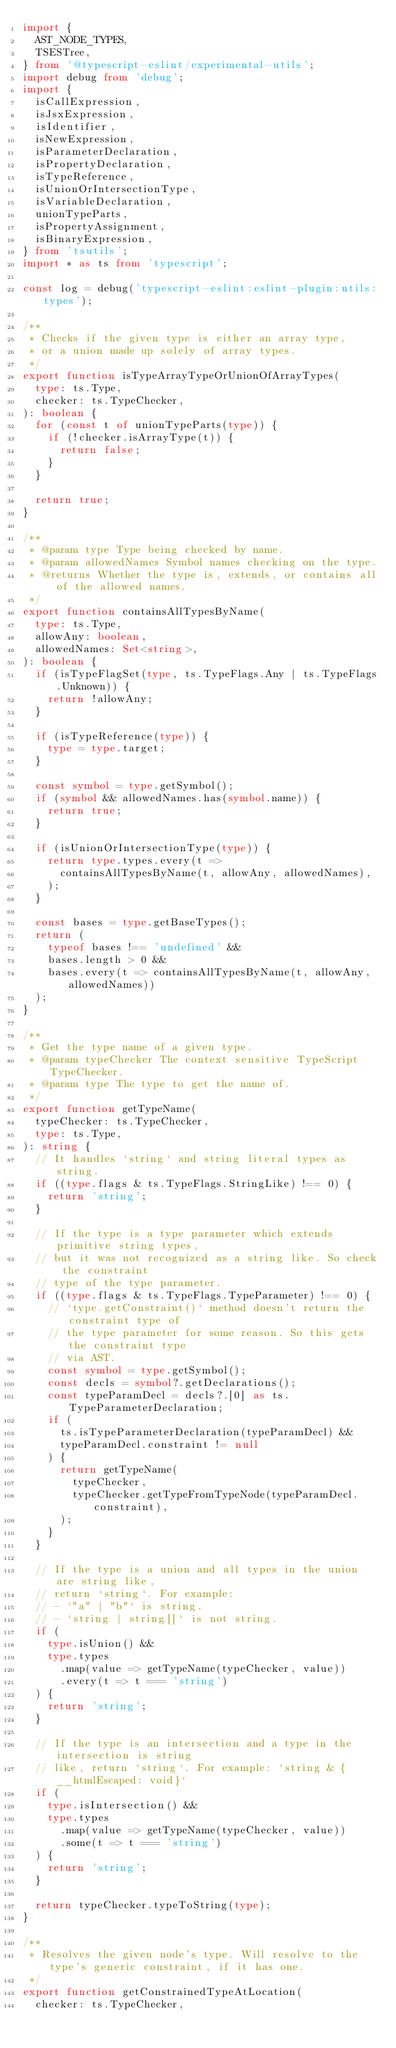<code> <loc_0><loc_0><loc_500><loc_500><_TypeScript_>import {
  AST_NODE_TYPES,
  TSESTree,
} from '@typescript-eslint/experimental-utils';
import debug from 'debug';
import {
  isCallExpression,
  isJsxExpression,
  isIdentifier,
  isNewExpression,
  isParameterDeclaration,
  isPropertyDeclaration,
  isTypeReference,
  isUnionOrIntersectionType,
  isVariableDeclaration,
  unionTypeParts,
  isPropertyAssignment,
  isBinaryExpression,
} from 'tsutils';
import * as ts from 'typescript';

const log = debug('typescript-eslint:eslint-plugin:utils:types');

/**
 * Checks if the given type is either an array type,
 * or a union made up solely of array types.
 */
export function isTypeArrayTypeOrUnionOfArrayTypes(
  type: ts.Type,
  checker: ts.TypeChecker,
): boolean {
  for (const t of unionTypeParts(type)) {
    if (!checker.isArrayType(t)) {
      return false;
    }
  }

  return true;
}

/**
 * @param type Type being checked by name.
 * @param allowedNames Symbol names checking on the type.
 * @returns Whether the type is, extends, or contains all of the allowed names.
 */
export function containsAllTypesByName(
  type: ts.Type,
  allowAny: boolean,
  allowedNames: Set<string>,
): boolean {
  if (isTypeFlagSet(type, ts.TypeFlags.Any | ts.TypeFlags.Unknown)) {
    return !allowAny;
  }

  if (isTypeReference(type)) {
    type = type.target;
  }

  const symbol = type.getSymbol();
  if (symbol && allowedNames.has(symbol.name)) {
    return true;
  }

  if (isUnionOrIntersectionType(type)) {
    return type.types.every(t =>
      containsAllTypesByName(t, allowAny, allowedNames),
    );
  }

  const bases = type.getBaseTypes();
  return (
    typeof bases !== 'undefined' &&
    bases.length > 0 &&
    bases.every(t => containsAllTypesByName(t, allowAny, allowedNames))
  );
}

/**
 * Get the type name of a given type.
 * @param typeChecker The context sensitive TypeScript TypeChecker.
 * @param type The type to get the name of.
 */
export function getTypeName(
  typeChecker: ts.TypeChecker,
  type: ts.Type,
): string {
  // It handles `string` and string literal types as string.
  if ((type.flags & ts.TypeFlags.StringLike) !== 0) {
    return 'string';
  }

  // If the type is a type parameter which extends primitive string types,
  // but it was not recognized as a string like. So check the constraint
  // type of the type parameter.
  if ((type.flags & ts.TypeFlags.TypeParameter) !== 0) {
    // `type.getConstraint()` method doesn't return the constraint type of
    // the type parameter for some reason. So this gets the constraint type
    // via AST.
    const symbol = type.getSymbol();
    const decls = symbol?.getDeclarations();
    const typeParamDecl = decls?.[0] as ts.TypeParameterDeclaration;
    if (
      ts.isTypeParameterDeclaration(typeParamDecl) &&
      typeParamDecl.constraint != null
    ) {
      return getTypeName(
        typeChecker,
        typeChecker.getTypeFromTypeNode(typeParamDecl.constraint),
      );
    }
  }

  // If the type is a union and all types in the union are string like,
  // return `string`. For example:
  // - `"a" | "b"` is string.
  // - `string | string[]` is not string.
  if (
    type.isUnion() &&
    type.types
      .map(value => getTypeName(typeChecker, value))
      .every(t => t === 'string')
  ) {
    return 'string';
  }

  // If the type is an intersection and a type in the intersection is string
  // like, return `string`. For example: `string & {__htmlEscaped: void}`
  if (
    type.isIntersection() &&
    type.types
      .map(value => getTypeName(typeChecker, value))
      .some(t => t === 'string')
  ) {
    return 'string';
  }

  return typeChecker.typeToString(type);
}

/**
 * Resolves the given node's type. Will resolve to the type's generic constraint, if it has one.
 */
export function getConstrainedTypeAtLocation(
  checker: ts.TypeChecker,</code> 